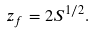<formula> <loc_0><loc_0><loc_500><loc_500>z _ { f } = 2 S ^ { 1 / 2 } .</formula> 